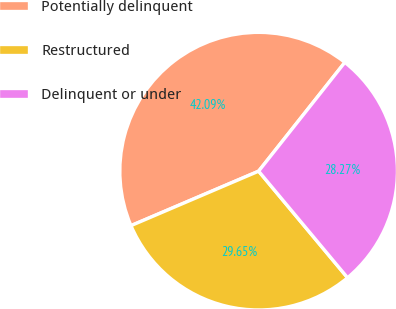Convert chart. <chart><loc_0><loc_0><loc_500><loc_500><pie_chart><fcel>Potentially delinquent<fcel>Restructured<fcel>Delinquent or under<nl><fcel>42.09%<fcel>29.65%<fcel>28.27%<nl></chart> 